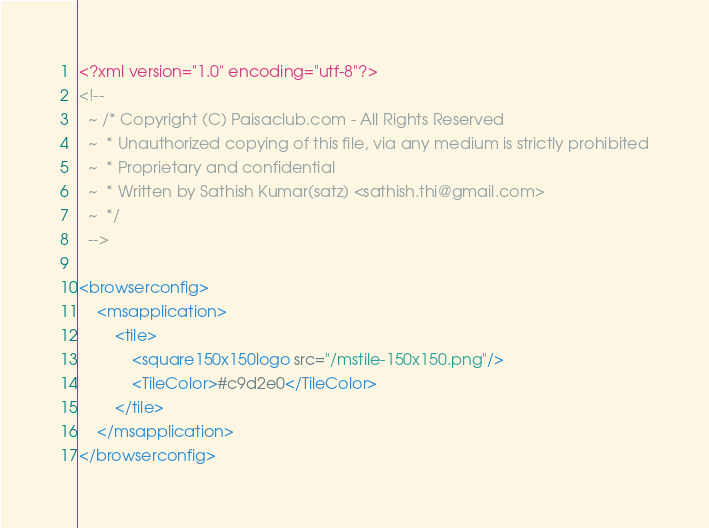<code> <loc_0><loc_0><loc_500><loc_500><_XML_><?xml version="1.0" encoding="utf-8"?>
<!--
  ~ /* Copyright (C) Paisaclub.com - All Rights Reserved
  ~  * Unauthorized copying of this file, via any medium is strictly prohibited
  ~  * Proprietary and confidential
  ~  * Written by Sathish Kumar(satz) <sathish.thi@gmail.com>
  ~  */
  -->

<browserconfig>
    <msapplication>
        <tile>
            <square150x150logo src="/mstile-150x150.png"/>
            <TileColor>#c9d2e0</TileColor>
        </tile>
    </msapplication>
</browserconfig>
</code> 